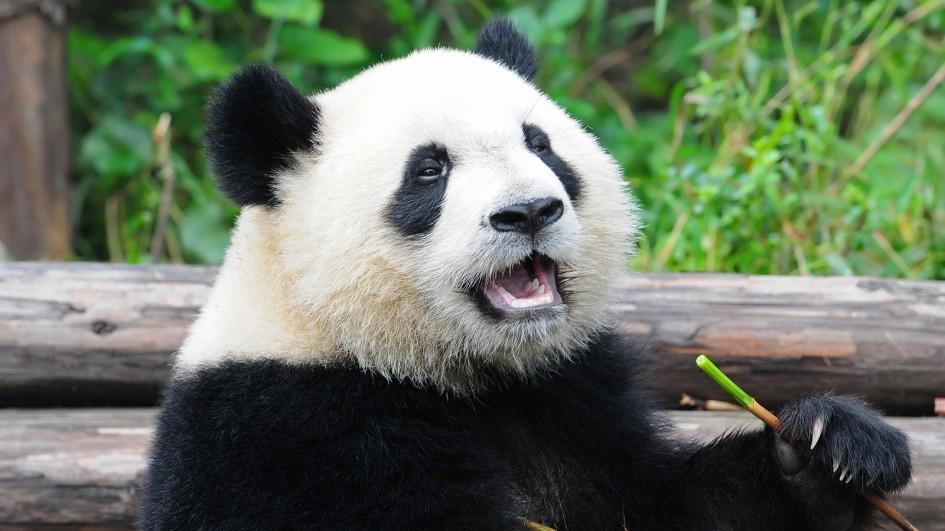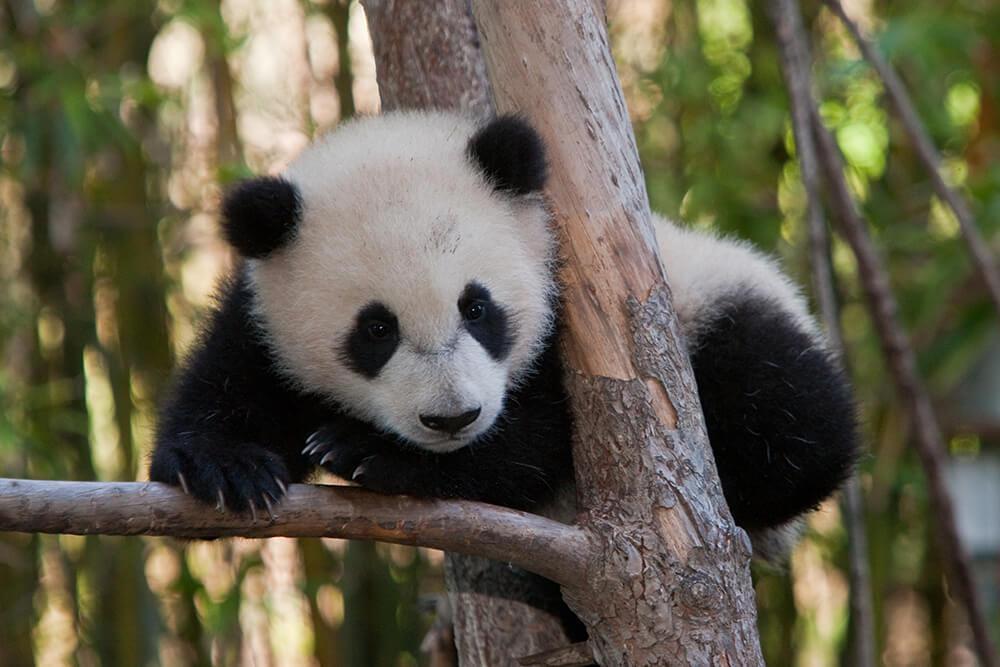The first image is the image on the left, the second image is the image on the right. Evaluate the accuracy of this statement regarding the images: "The panda is sitting on top of a tree branch in the right image.". Is it true? Answer yes or no. Yes. 